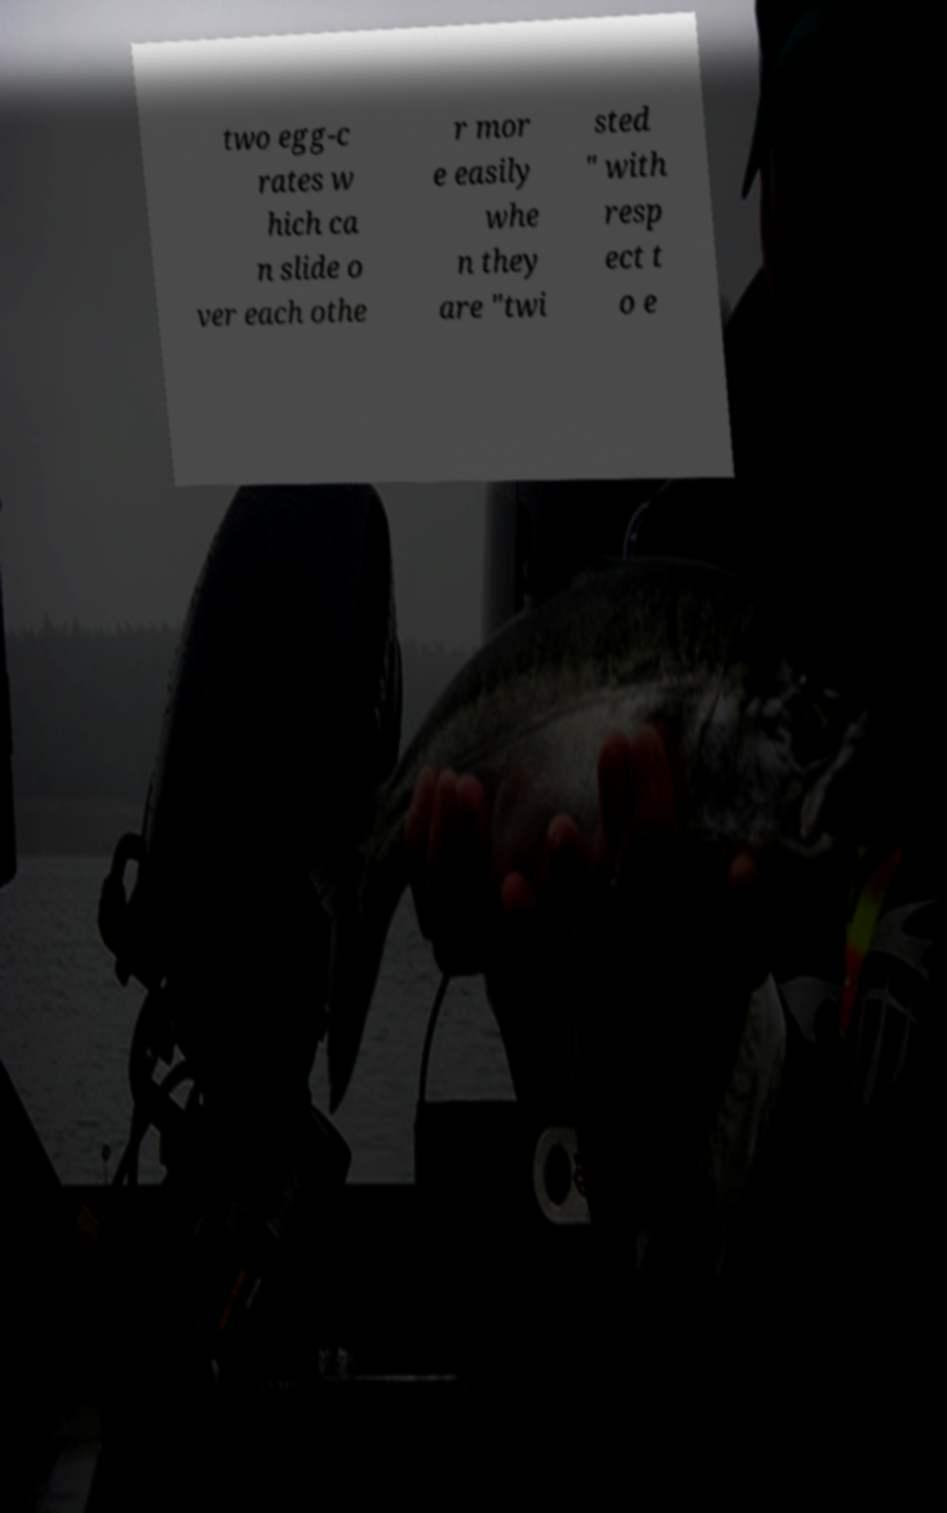Can you accurately transcribe the text from the provided image for me? two egg-c rates w hich ca n slide o ver each othe r mor e easily whe n they are "twi sted " with resp ect t o e 